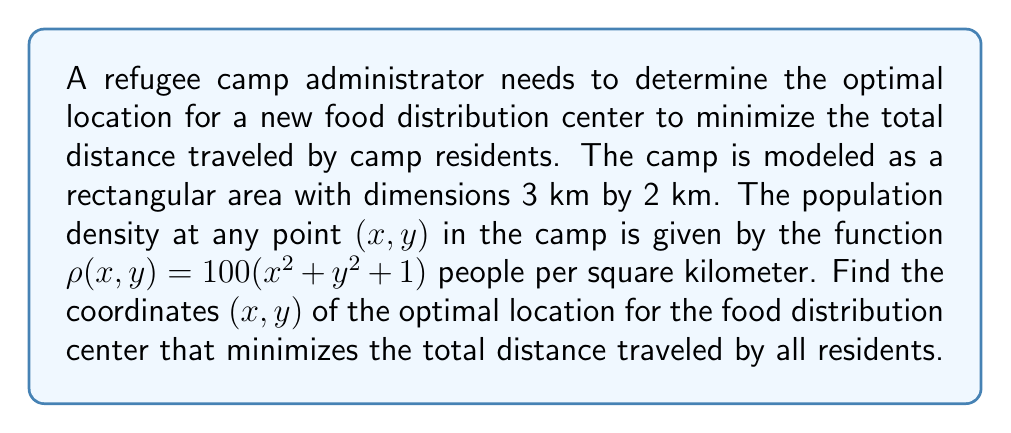Can you answer this question? To solve this problem, we'll use vector calculus and the concept of center of mass. The optimal location for the food distribution center will be at the center of mass of the population distribution.

1. First, we need to set up the integrals for the total mass (population) and the moments:

   Total mass: $M = \iint_R \rho(x,y) \, dA$
   Moment about y-axis: $M_y = \iint_R x\rho(x,y) \, dA$
   Moment about x-axis: $M_x = \iint_R y\rho(x,y) \, dA$

   Where R is the rectangular region $0 \leq x \leq 3$ and $0 \leq y \leq 2$.

2. Calculate the total mass:
   $$\begin{align*}
   M &= \int_0^2 \int_0^3 100(x^2 + y^2 + 1) \, dx \, dy \\
   &= 100 \int_0^2 \left[\frac{x^3}{3} + xy^2 + x\right]_0^3 \, dy \\
   &= 100 \int_0^2 (9 + 3y^2 + 3) \, dy \\
   &= 100 \left[12y + y^3\right]_0^2 \\
   &= 100(24 + 8) = 3200
   \end{align*}$$

3. Calculate the moment about the y-axis:
   $$\begin{align*}
   M_y &= \int_0^2 \int_0^3 100x(x^2 + y^2 + 1) \, dx \, dy \\
   &= 100 \int_0^2 \left[\frac{x^4}{4} + \frac{x^2y^2}{2} + \frac{x^2}{2}\right]_0^3 \, dy \\
   &= 100 \int_0^2 \left(\frac{81}{4} + \frac{9y^2}{2} + \frac{9}{2}\right) \, dy \\
   &= 100 \left[\frac{81y}{4} + \frac{3y^3}{2} + \frac{9y}{2}\right]_0^2 \\
   &= 100(40.5 + 12 + 9) = 6150
   \end{align*}$$

4. Calculate the moment about the x-axis:
   $$\begin{align*}
   M_x &= \int_0^2 \int_0^3 100y(x^2 + y^2 + 1) \, dx \, dy \\
   &= 100 \int_0^2 y\left[x^3/3 + xy^2 + x\right]_0^3 \, dy \\
   &= 100 \int_0^2 y(9 + 3y^2 + 3) \, dy \\
   &= 100 \left[\frac{9y^2}{2} + \frac{3y^4}{4} + \frac{3y^2}{2}\right]_0^2 \\
   &= 100(18 + 12 + 6) = 3600
   \end{align*}$$

5. The center of mass coordinates are given by:
   $$x_{cm} = \frac{M_y}{M} = \frac{6150}{3200} = 1.921875$$
   $$y_{cm} = \frac{M_x}{M} = \frac{3600}{3200} = 1.125$$

Therefore, the optimal location for the food distribution center is at (1.921875, 1.125) km from the origin of the coordinate system.
Answer: The optimal location for the food distribution center is at coordinates (1.921875, 1.125) km. 